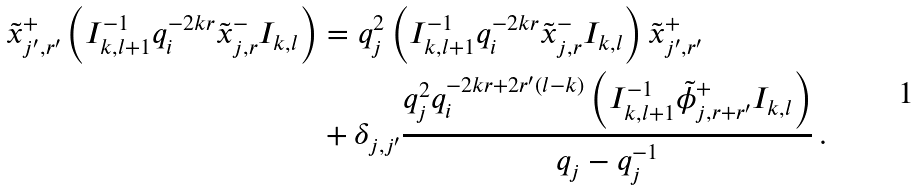Convert formula to latex. <formula><loc_0><loc_0><loc_500><loc_500>\tilde { x } _ { j ^ { \prime } , r ^ { \prime } } ^ { + } \left ( I _ { k , l + 1 } ^ { - 1 } q _ { i } ^ { - 2 k r } \tilde { x } _ { j , r } ^ { - } I _ { k , l } \right ) & = q _ { j } ^ { 2 } \left ( I _ { k , l + 1 } ^ { - 1 } q _ { i } ^ { - 2 k r } \tilde { x } _ { j , r } ^ { - } I _ { k , l } \right ) \tilde { x } _ { j ^ { \prime } , r ^ { \prime } } ^ { + } \\ & + \delta _ { j , j ^ { \prime } } \frac { q _ { j } ^ { 2 } q _ { i } ^ { - 2 k r + 2 r ^ { \prime } ( l - k ) } \left ( I _ { k , l + 1 } ^ { - 1 } \tilde { \phi } _ { j , r + r ^ { \prime } } ^ { + } I _ { k , l } \right ) } { q _ { j } - q _ { j } ^ { - 1 } } \, .</formula> 